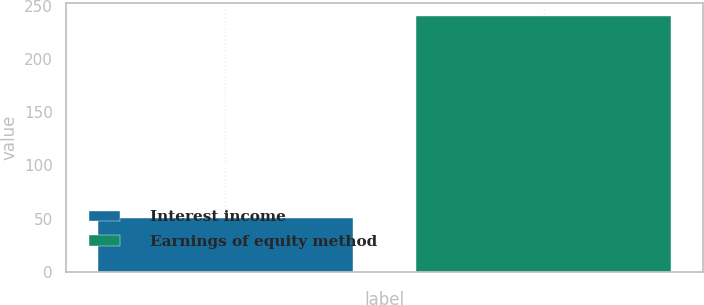Convert chart to OTSL. <chart><loc_0><loc_0><loc_500><loc_500><bar_chart><fcel>Interest income<fcel>Earnings of equity method<nl><fcel>51<fcel>240<nl></chart> 